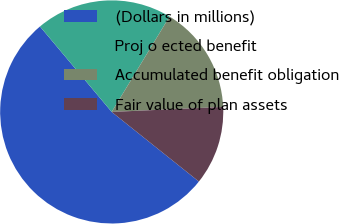Convert chart to OTSL. <chart><loc_0><loc_0><loc_500><loc_500><pie_chart><fcel>(Dollars in millions)<fcel>Proj o ected benefit<fcel>Accumulated benefit obligation<fcel>Fair value of plan assets<nl><fcel>53.16%<fcel>19.79%<fcel>15.61%<fcel>11.44%<nl></chart> 